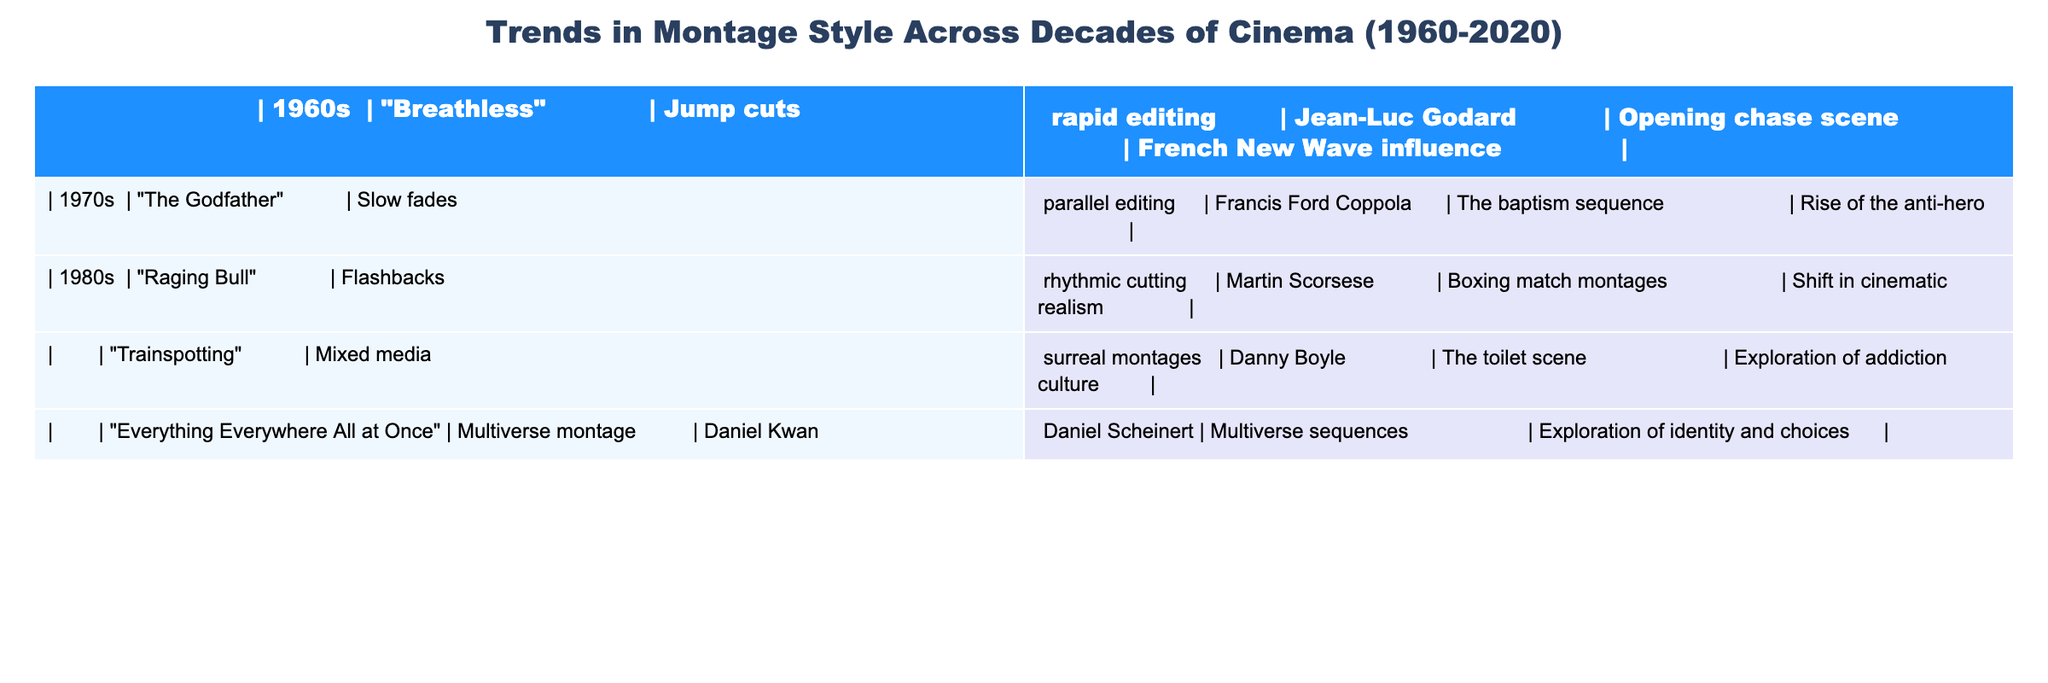What montage style is featured in "Breathless"? The table lists "Breathless" under the 1960s, where the montage style is specified as "Jump cuts, rapid editing."
Answer: Jump cuts, rapid editing Which director is associated with "The Godfather"? In the table, "The Godfather" is linked to Francis Ford Coppola, which is stated in the director column.
Answer: Francis Ford Coppola Did the 1980s see a rise in the exploration of addiction culture in montage style? The table indicates that "Trainspotting," a film from the 1980s, explores addiction culture, confirming that this theme is present in that decade.
Answer: Yes What is the common theme explored in the montage styles of the 2020 film "Everything Everywhere All at Once"? According to the table, the film explores "identity and choices," which is noted in the thematic column.
Answer: Exploration of identity and choices How many films listed utilize flashbacks as a montage style? The table shows that only "Raging Bull" employs "Flashbacks, rhythmic cutting." Therefore, the total count is 1.
Answer: 1 Which decade features the film "Raging Bull," and what editing style does it use? "Raging Bull" is included in the 1980s, and the table specifies its editing style as "Flashbacks, rhythmic cutting."
Answer: 1980s; Flashbacks, rhythmic cutting Is "Everything Everywhere All at Once" the only film in the table that features multiverse sequences? The table clearly states that "Everything Everywhere All at Once" showcases a "Multiverse montage," and no other film in the table mentions similar themes, indicating it is the only one.
Answer: Yes Compare the major themes of "The Godfather" and "Trainspotting." "The Godfather" highlights the rise of the anti-hero, while "Trainspotting" delves into addiction culture. This comparison shows contrasting themes related to Morality vs. Societal issues.
Answer: Anti-hero vs. Addiction culture What is the trend in montage styles from the 1960s to the 2020s? Analyzing the table, it shows a shift from "Jump cuts, rapid editing" in the 1960s to a complex "Multiverse montage" in the 2020s, signifying increased complexity and themes of identity.
Answer: Increased complexity and themes of identity Which film features slow fades and parallel editing? "The Godfather" is the only film noted for utilizing slow fades and parallel editing, as indicated in the table.
Answer: The Godfather How do the montage styles of the 1960s and 1980s differ? The 1960s utilize "Jump cuts, rapid editing," while the 1980s show "Flashbacks, rhythmic cutting" and mixed media stylings. This marks a significant evolution in editing approaches over the decades.
Answer: They differ in style; 1960s used jump cuts, while 1980s used flashbacks 